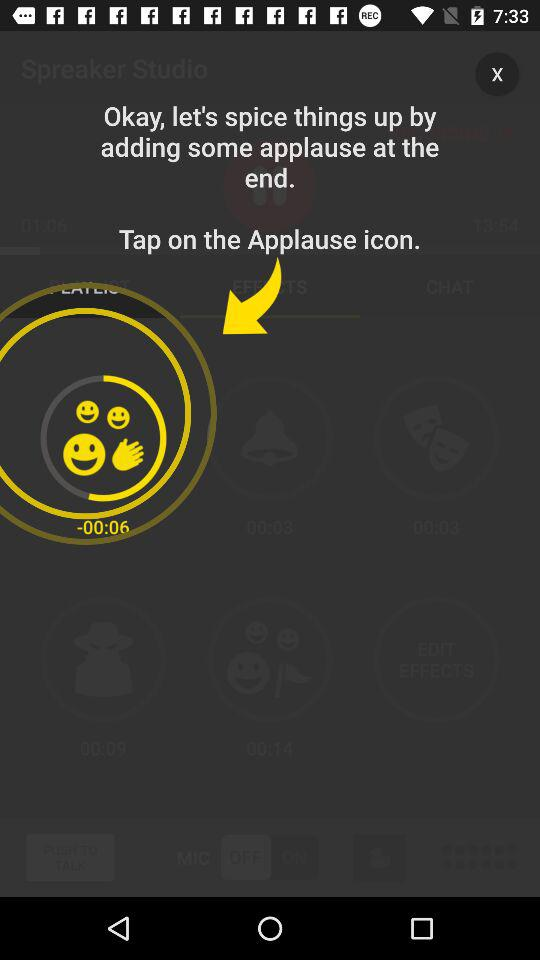What is the application name? The application name is "Spreaker Studio". 